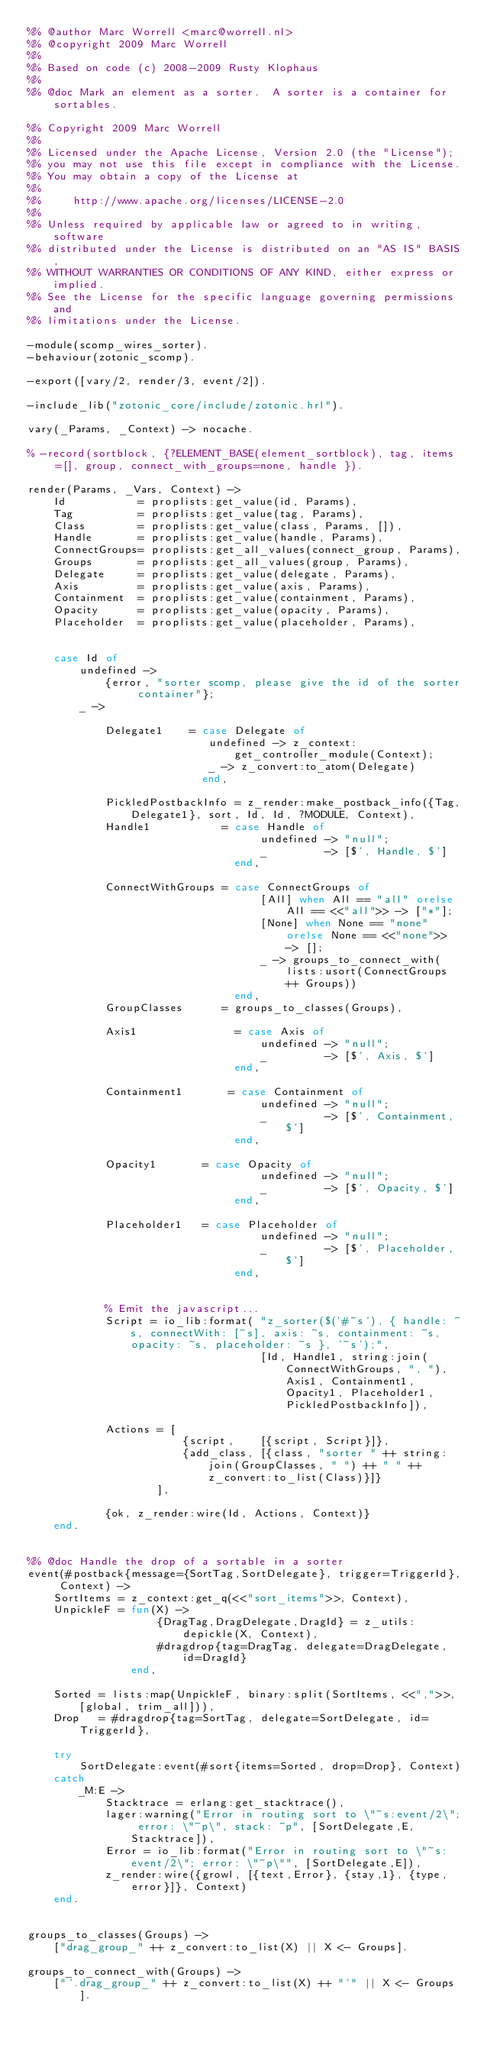Convert code to text. <code><loc_0><loc_0><loc_500><loc_500><_Erlang_>%% @author Marc Worrell <marc@worrell.nl>
%% @copyright 2009 Marc Worrell
%%
%% Based on code (c) 2008-2009 Rusty Klophaus
%%
%% @doc Mark an element as a sorter.  A sorter is a container for sortables.

%% Copyright 2009 Marc Worrell
%%
%% Licensed under the Apache License, Version 2.0 (the "License");
%% you may not use this file except in compliance with the License.
%% You may obtain a copy of the License at
%%
%%     http://www.apache.org/licenses/LICENSE-2.0
%%
%% Unless required by applicable law or agreed to in writing, software
%% distributed under the License is distributed on an "AS IS" BASIS,
%% WITHOUT WARRANTIES OR CONDITIONS OF ANY KIND, either express or implied.
%% See the License for the specific language governing permissions and
%% limitations under the License.

-module(scomp_wires_sorter).
-behaviour(zotonic_scomp).

-export([vary/2, render/3, event/2]).

-include_lib("zotonic_core/include/zotonic.hrl").

vary(_Params, _Context) -> nocache.

% -record(sortblock, {?ELEMENT_BASE(element_sortblock), tag, items=[], group, connect_with_groups=none, handle }).

render(Params, _Vars, Context) ->
    Id           = proplists:get_value(id, Params),
    Tag          = proplists:get_value(tag, Params),
    Class        = proplists:get_value(class, Params, []),
    Handle       = proplists:get_value(handle, Params),
    ConnectGroups= proplists:get_all_values(connect_group, Params),
    Groups       = proplists:get_all_values(group, Params),
    Delegate     = proplists:get_value(delegate, Params),
    Axis     	 = proplists:get_value(axis, Params),
	Containment	 = proplists:get_value(containment, Params),
	Opacity	 	 = proplists:get_value(opacity, Params),
	Placeholder	 = proplists:get_value(placeholder, Params),


    case Id of
        undefined ->
            {error, "sorter scomp, please give the id of the sorter container"};
        _ ->

			Delegate1	 = case Delegate of
							undefined -> z_context:get_controller_module(Context);
							_ -> z_convert:to_atom(Delegate)
						   end,

			PickledPostbackInfo = z_render:make_postback_info({Tag,Delegate1}, sort, Id, Id, ?MODULE, Context),
			Handle1			  = case Handle of
									undefined -> "null";
									_		  -> [$', Handle, $']
								end,

			ConnectWithGroups = case ConnectGroups of
									[All] when All == "all" orelse All == <<"all">> -> ["*"];
									[None] when None == "none" orelse None == <<"none">> -> [];
									_ -> groups_to_connect_with(lists:usort(ConnectGroups ++ Groups))
								end,
			GroupClasses	  = groups_to_classes(Groups),

			Axis1				= case Axis of
									undefined -> "null";
									_		  -> [$', Axis, $']
								end,

			Containment1	   = case Containment of
									undefined -> "null";
									_		  -> [$', Containment, $']
								end,

			Opacity1	   = case Opacity of
									undefined -> "null";
									_		  -> [$', Opacity, $']
								end,

			Placeholder1   = case Placeholder of
									undefined -> "null";
									_		  -> [$', Placeholder, $']
								end,


        	% Emit the javascript...
        	Script = io_lib:format( "z_sorter($('#~s'), { handle: ~s, connectWith: [~s], axis: ~s, containment: ~s, opacity: ~s, placeholder: ~s }, '~s');",
        	                        [Id, Handle1, string:join(ConnectWithGroups, ", "), Axis1, Containment1, Opacity1, Placeholder1, PickledPostbackInfo]),

            Actions = [
                        {script,    [{script, Script}]},
                        {add_class, [{class, "sorter " ++ string:join(GroupClasses, " ") ++ " " ++ z_convert:to_list(Class)}]}
                    ],

    	    {ok, z_render:wire(Id, Actions, Context)}
    end.


%% @doc Handle the drop of a sortable in a sorter
event(#postback{message={SortTag,SortDelegate}, trigger=TriggerId}, Context) ->
	SortItems = z_context:get_q(<<"sort_items">>, Context),
    UnpickleF = fun(X) ->
                    {DragTag,DragDelegate,DragId} = z_utils:depickle(X, Context),
                    #dragdrop{tag=DragTag, delegate=DragDelegate, id=DragId}
                end,

    Sorted = lists:map(UnpickleF, binary:split(SortItems, <<",">>, [global, trim_all])),
    Drop   = #dragdrop{tag=SortTag, delegate=SortDelegate, id=TriggerId},

	try
	    SortDelegate:event(#sort{items=Sorted, drop=Drop}, Context)
    catch
        _M:E ->
        	Stacktrace = erlang:get_stacktrace(),
        	lager:warning("Error in routing sort to \"~s:event/2\"; error: \"~p\", stack: ~p", [SortDelegate,E, Stacktrace]),
            Error = io_lib:format("Error in routing sort to \"~s:event/2\"; error: \"~p\"", [SortDelegate,E]),
            z_render:wire({growl, [{text,Error}, {stay,1}, {type, error}]}, Context)
    end.


groups_to_classes(Groups) ->
	["drag_group_" ++ z_convert:to_list(X) || X <- Groups].

groups_to_connect_with(Groups) ->
	["'.drag_group_" ++ z_convert:to_list(X) ++ "'" || X <- Groups].
</code> 